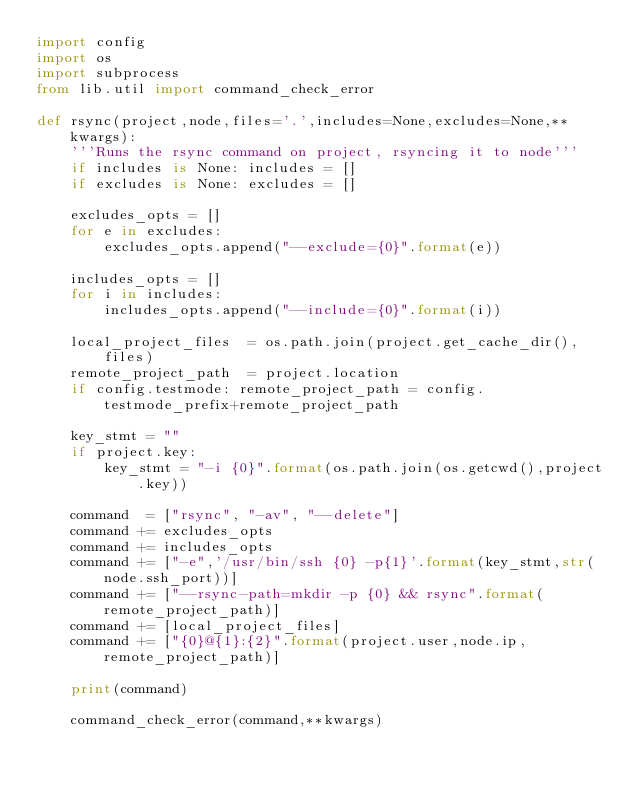Convert code to text. <code><loc_0><loc_0><loc_500><loc_500><_Python_>import config
import os
import subprocess
from lib.util import command_check_error

def rsync(project,node,files='.',includes=None,excludes=None,**kwargs):
    '''Runs the rsync command on project, rsyncing it to node'''
    if includes is None: includes = []
    if excludes is None: excludes = []

    excludes_opts = []
    for e in excludes:
        excludes_opts.append("--exclude={0}".format(e))

    includes_opts = []
    for i in includes:
        includes_opts.append("--include={0}".format(i))

    local_project_files  = os.path.join(project.get_cache_dir(),files)
    remote_project_path  = project.location
    if config.testmode: remote_project_path = config.testmode_prefix+remote_project_path

    key_stmt = ""
    if project.key:
        key_stmt = "-i {0}".format(os.path.join(os.getcwd(),project.key))

    command  = ["rsync", "-av", "--delete"]
    command += excludes_opts
    command += includes_opts
    command += ["-e",'/usr/bin/ssh {0} -p{1}'.format(key_stmt,str(node.ssh_port))]
    command += ["--rsync-path=mkdir -p {0} && rsync".format(remote_project_path)]
    command += [local_project_files]
    command += ["{0}@{1}:{2}".format(project.user,node.ip,remote_project_path)]

    print(command)

    command_check_error(command,**kwargs)
</code> 